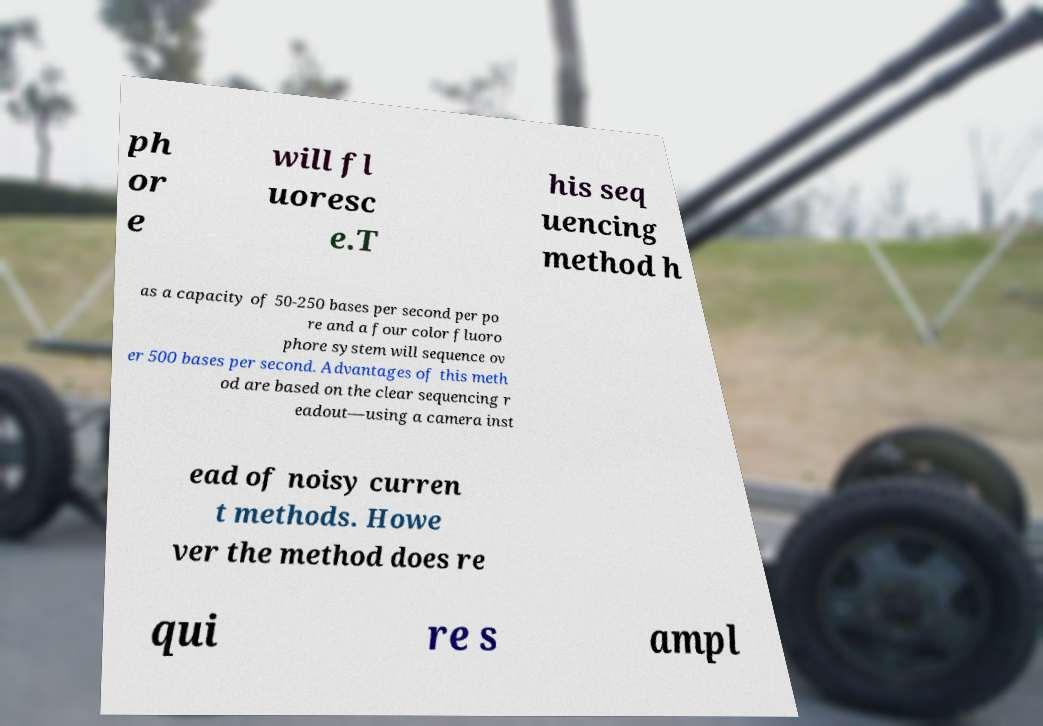Could you assist in decoding the text presented in this image and type it out clearly? ph or e will fl uoresc e.T his seq uencing method h as a capacity of 50-250 bases per second per po re and a four color fluoro phore system will sequence ov er 500 bases per second. Advantages of this meth od are based on the clear sequencing r eadout—using a camera inst ead of noisy curren t methods. Howe ver the method does re qui re s ampl 